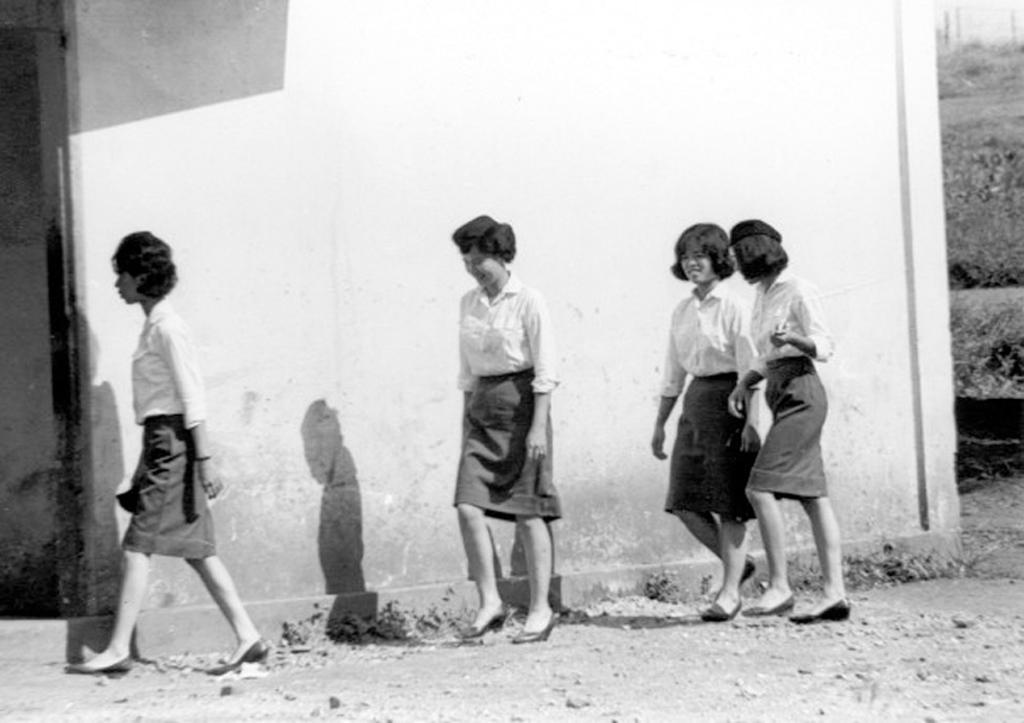Please provide a concise description of this image. On the left side, there is a woman in a skirt, walking on a road, on which there are stones. On the right side, there are three women in skirts on the road. In the background, there is a white wall and there are plants. 